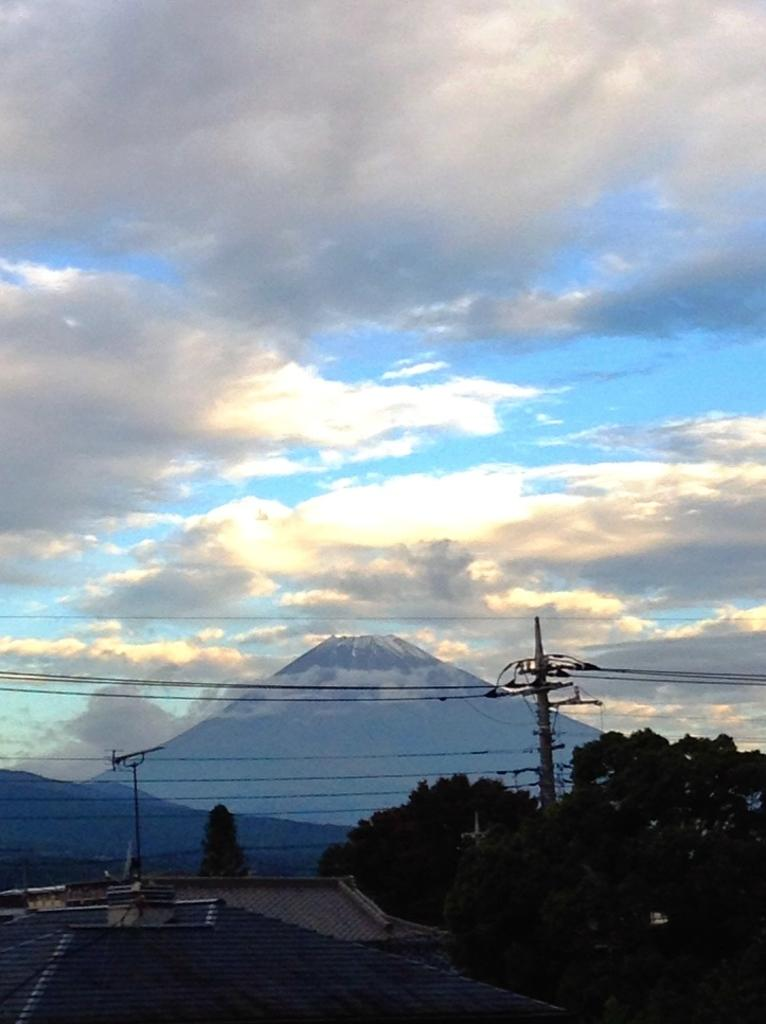What can be seen in the sky in the image? The sky is visible in the image. What structures are present in the image that have wires attached? There are poles with wires attached in the image. What type of vegetation is present in the image? Trees are present in the image. What type of structures have roofs visible in the image? Roofs are visible in the image. Where are the tomatoes growing in the image? There are no tomatoes present in the image. What type of hole can be seen in the roof of the building in the image? There is no hole visible in the roof of any building in the image. 